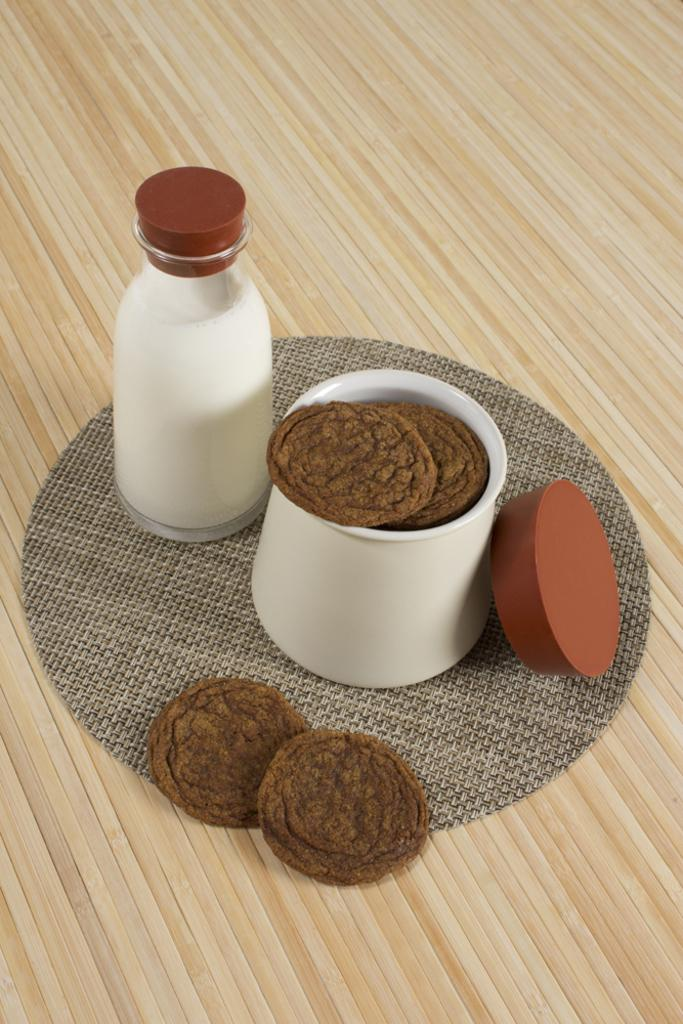What is in the foreground of the image? There is a circular table mat in the foreground of the image. Where is the table mat located? The table mat is on a table. What is placed on the table mat? There are cookies on the table mat, as well as a lid and a bowl with cookies. What is the purpose of the lid on the table mat? The purpose of the lid is not explicitly mentioned, but it could be used to cover the bowl or the cookies. What is the milk bottle used for? The milk bottle is likely used for serving milk with the cookies. What holiday is being celebrated in the image? There is no indication of a holiday being celebrated in the image. Can you recite a verse that is written on the table mat? There is no verse written on the table mat in the image. 